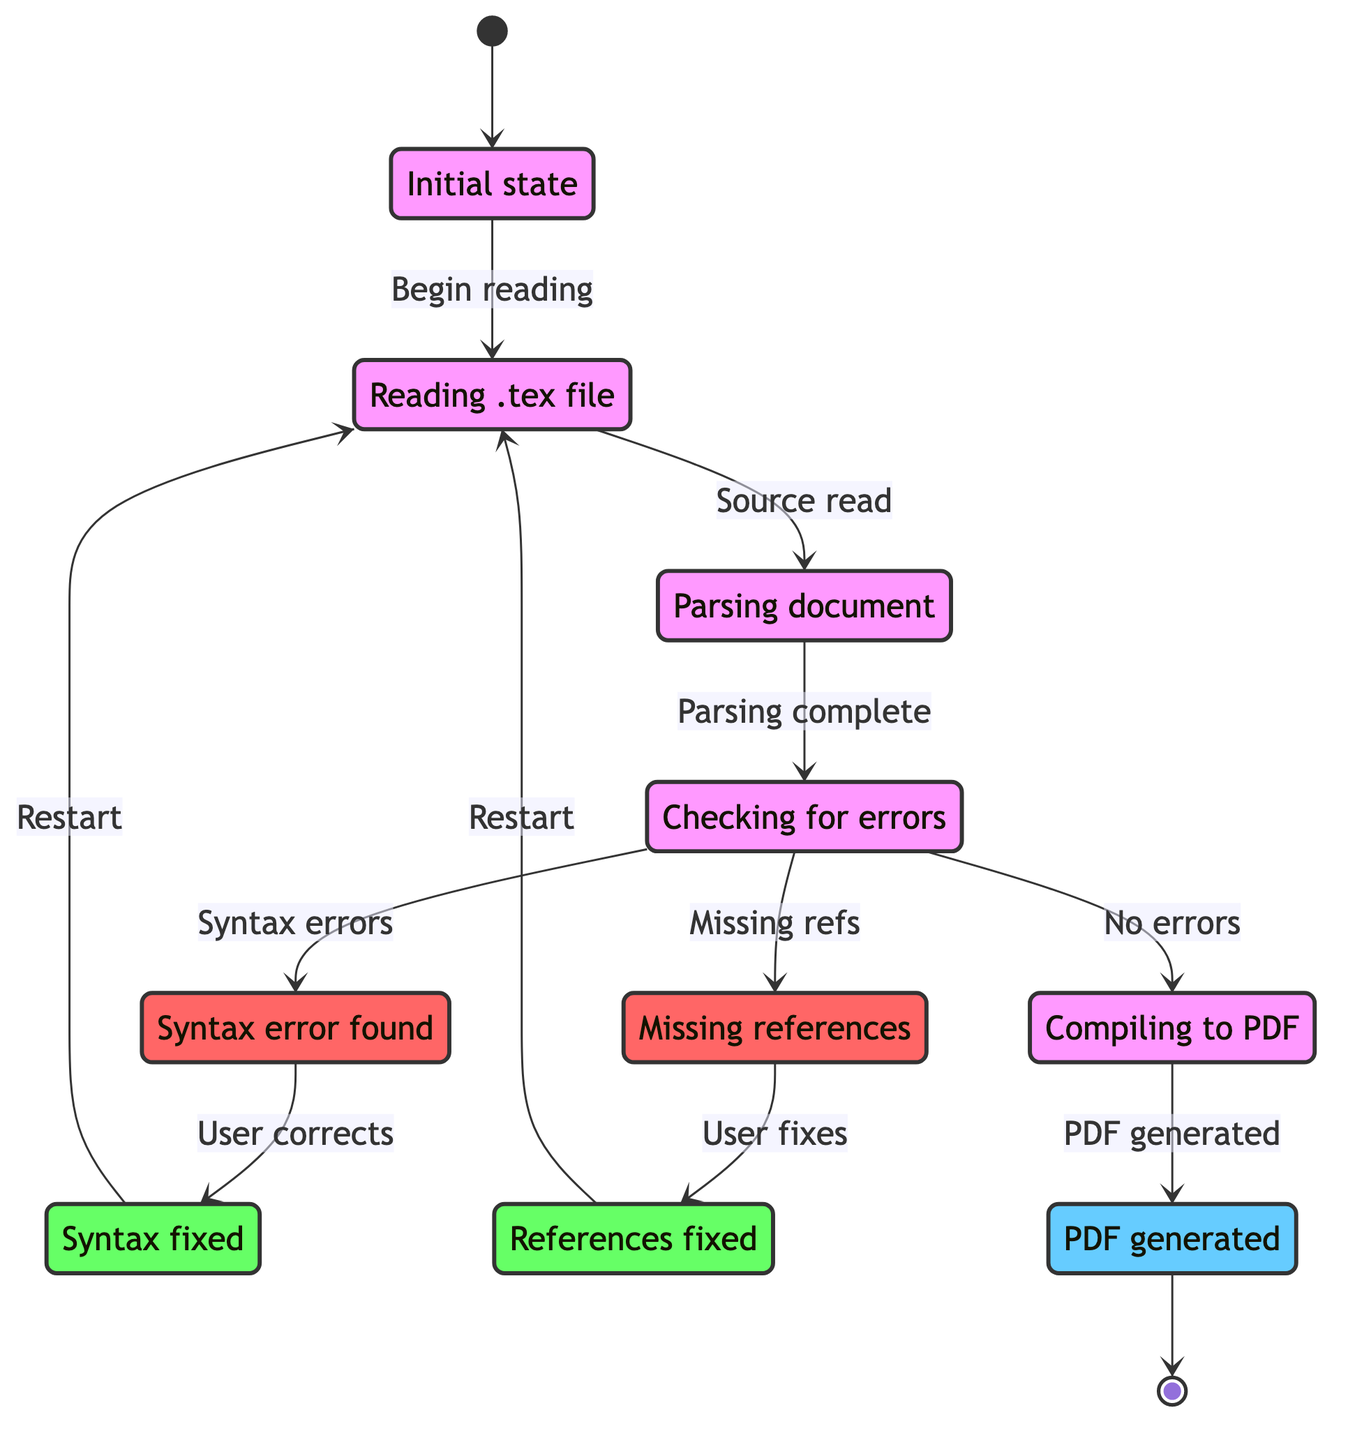What is the initial state of the compilation process? According to the diagram, the process starts at the "Start" state, which represents the initial phase before any actions are taken in the LaTeX document compilation.
Answer: Start How many error states are present in the diagram? By examining the diagram, there are two error states: "SyntaxError" and "MissingReferences." Therefore, the total count of error states is two.
Answer: 2 What state follows "ErrorCheck" if no errors are detected? In the diagram flow, if there are no errors when checking, the next state from "ErrorCheck" is "Compile," which indicates that the document will be compiled.
Answer: Compile What is the final state of the compilation process? The end point of the diagram indicates that the final state reached after the compilation process is "OutputGenerated," where the PDF output is successfully created.
Answer: OutputGenerated Which state do you return to after fixing syntax errors? According to the diagram, after correcting syntax errors in the "SyntaxError" state, the next action is to transition back to "ReadingSource" to restart the compilation process.
Answer: ReadingSource What occurs in the "Compile" state? The "Compile" state is specifically for the process of converting the parsed LaTeX document into a PDF file. Therefore, it indicates the act of compiling the document to generate the desired output.
Answer: Compiling to PDF Which state signifies user involvement to solve issues? The states "SyntaxError" and "MissingReferences" indicate the need for user intervention when errors or missing elements are found in the LaTeX document. Thus, these states show where the user must engage to correct problems.
Answer: SyntaxError, MissingReferences What is the transition condition from "ErrorCheck" to "Compile"? The condition for transitioning from "ErrorCheck" to "Compile" is that no errors are detected during the error checking phase, which allows the compilation to proceed.
Answer: No errors detected 